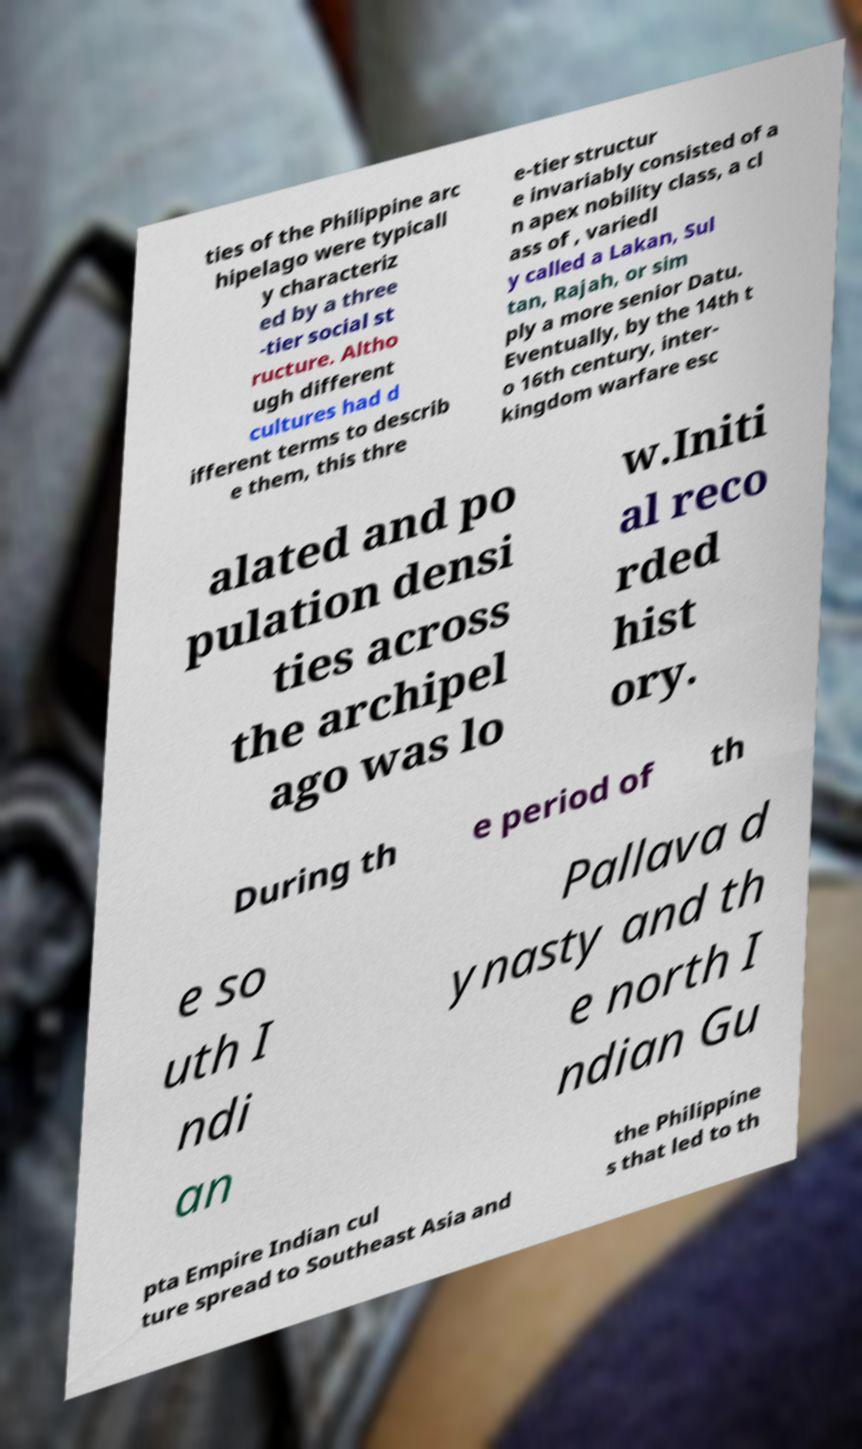What messages or text are displayed in this image? I need them in a readable, typed format. ties of the Philippine arc hipelago were typicall y characteriz ed by a three -tier social st ructure. Altho ugh different cultures had d ifferent terms to describ e them, this thre e-tier structur e invariably consisted of a n apex nobility class, a cl ass of , variedl y called a Lakan, Sul tan, Rajah, or sim ply a more senior Datu. Eventually, by the 14th t o 16th century, inter- kingdom warfare esc alated and po pulation densi ties across the archipel ago was lo w.Initi al reco rded hist ory. During th e period of th e so uth I ndi an Pallava d ynasty and th e north I ndian Gu pta Empire Indian cul ture spread to Southeast Asia and the Philippine s that led to th 